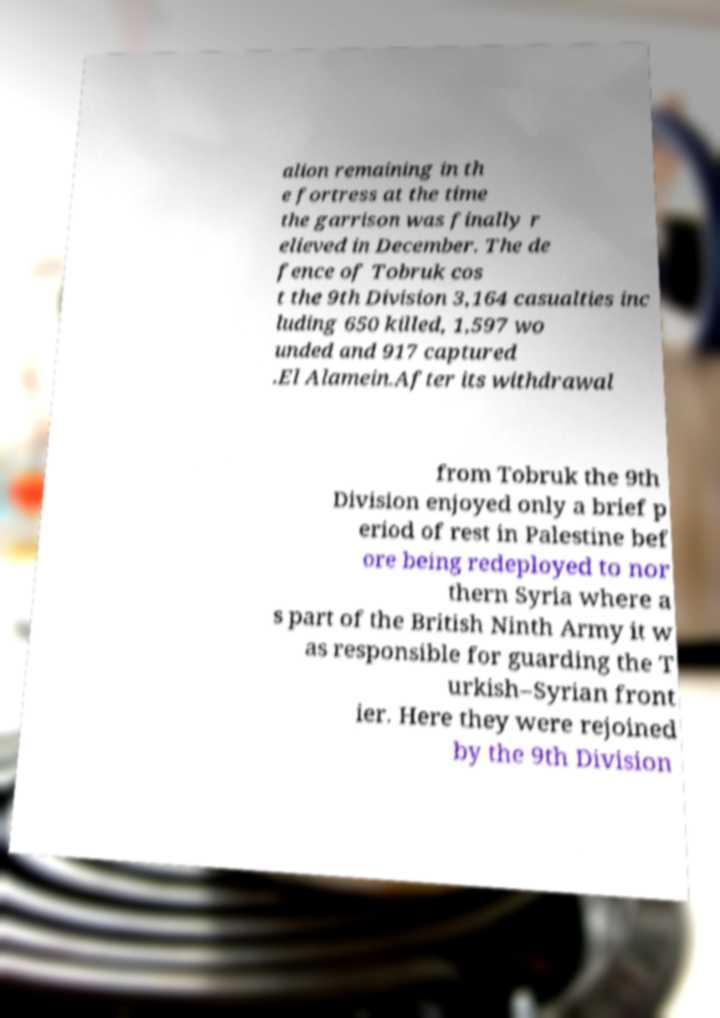Can you read and provide the text displayed in the image?This photo seems to have some interesting text. Can you extract and type it out for me? alion remaining in th e fortress at the time the garrison was finally r elieved in December. The de fence of Tobruk cos t the 9th Division 3,164 casualties inc luding 650 killed, 1,597 wo unded and 917 captured .El Alamein.After its withdrawal from Tobruk the 9th Division enjoyed only a brief p eriod of rest in Palestine bef ore being redeployed to nor thern Syria where a s part of the British Ninth Army it w as responsible for guarding the T urkish–Syrian front ier. Here they were rejoined by the 9th Division 